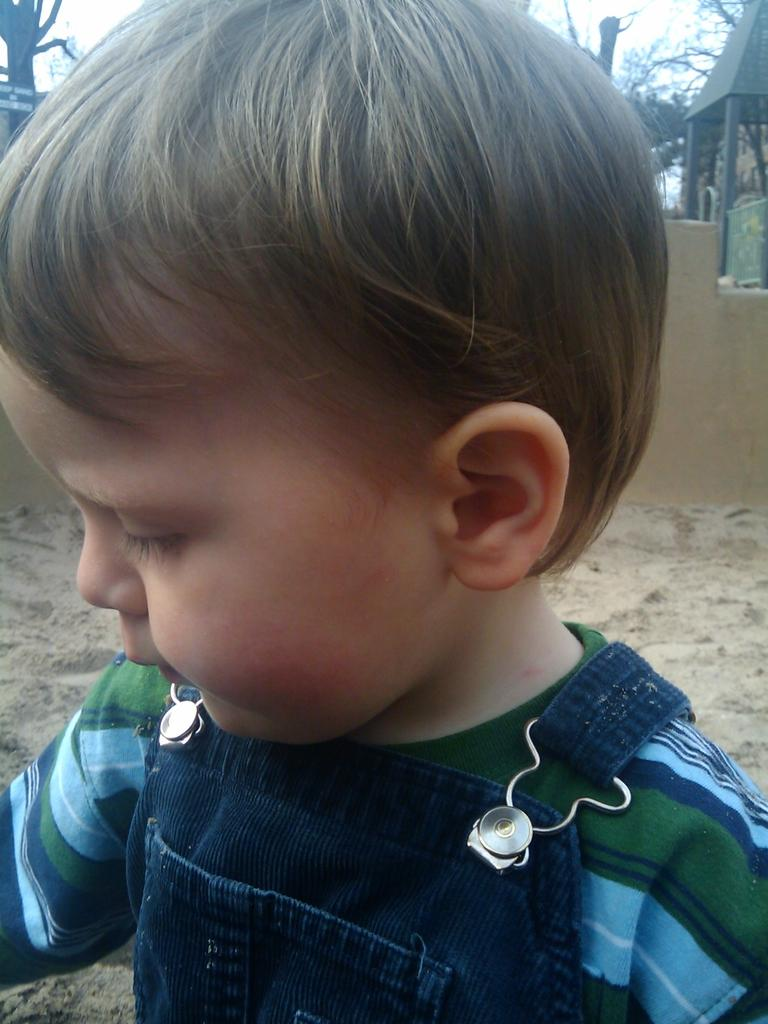What is the main subject of the image? There is a child in the image. What is the child standing on? The child is on sand. What can be seen in the background of the image? There are trees, a shelter, a wall, and the sky visible in the background of the image. What type of twig is the child holding in the image? There is no twig present in the image. What substance is the child applying to their skin in the image? There is no indication of the child applying any substance to their skin in the image. 